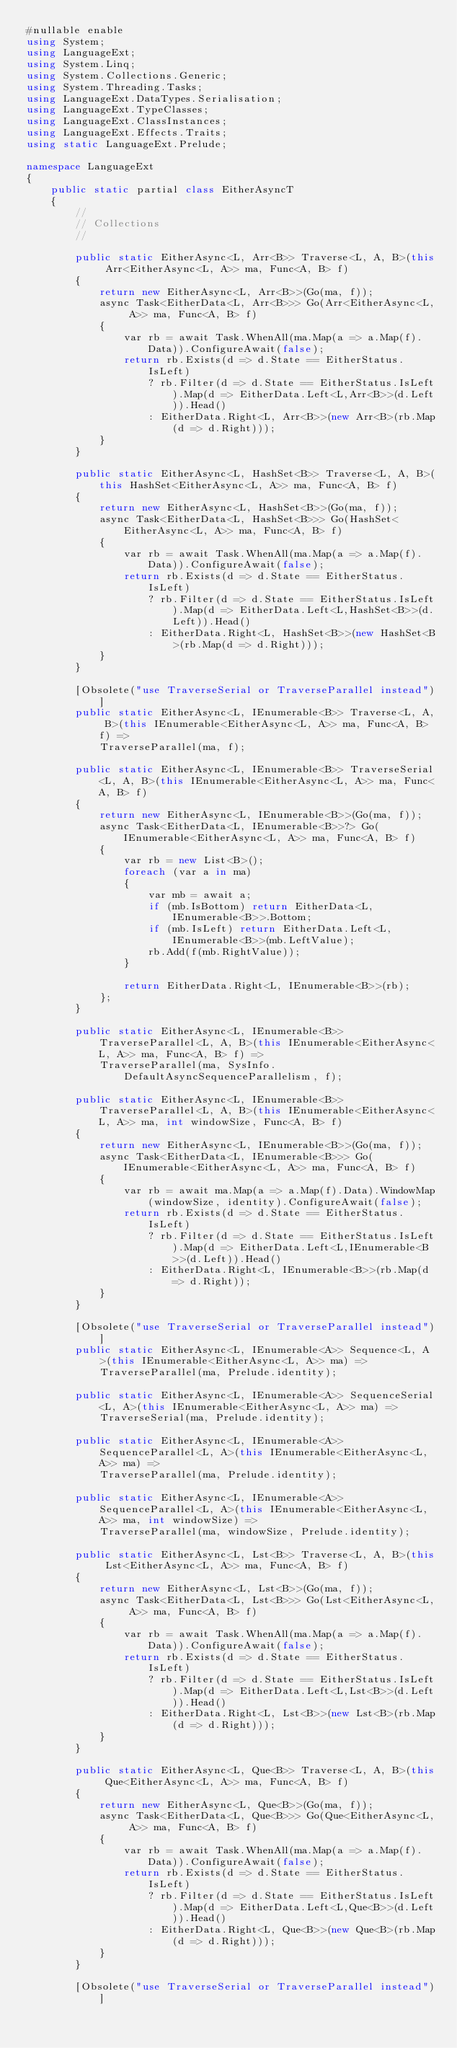<code> <loc_0><loc_0><loc_500><loc_500><_C#_>#nullable enable
using System;
using LanguageExt;
using System.Linq;
using System.Collections.Generic;
using System.Threading.Tasks;
using LanguageExt.DataTypes.Serialisation;
using LanguageExt.TypeClasses;
using LanguageExt.ClassInstances;
using LanguageExt.Effects.Traits;
using static LanguageExt.Prelude;

namespace LanguageExt
{
    public static partial class EitherAsyncT
    {
        //
        // Collections
        //

        public static EitherAsync<L, Arr<B>> Traverse<L, A, B>(this Arr<EitherAsync<L, A>> ma, Func<A, B> f)
        {
            return new EitherAsync<L, Arr<B>>(Go(ma, f));
            async Task<EitherData<L, Arr<B>>> Go(Arr<EitherAsync<L, A>> ma, Func<A, B> f)
            {
                var rb = await Task.WhenAll(ma.Map(a => a.Map(f).Data)).ConfigureAwait(false);
                return rb.Exists(d => d.State == EitherStatus.IsLeft)
                    ? rb.Filter(d => d.State == EitherStatus.IsLeft).Map(d => EitherData.Left<L,Arr<B>>(d.Left)).Head()
                    : EitherData.Right<L, Arr<B>>(new Arr<B>(rb.Map(d => d.Right)));
            }
        }

        public static EitherAsync<L, HashSet<B>> Traverse<L, A, B>(this HashSet<EitherAsync<L, A>> ma, Func<A, B> f)
        {
            return new EitherAsync<L, HashSet<B>>(Go(ma, f));
            async Task<EitherData<L, HashSet<B>>> Go(HashSet<EitherAsync<L, A>> ma, Func<A, B> f)
            {
                var rb = await Task.WhenAll(ma.Map(a => a.Map(f).Data)).ConfigureAwait(false);
                return rb.Exists(d => d.State == EitherStatus.IsLeft)
                    ? rb.Filter(d => d.State == EitherStatus.IsLeft).Map(d => EitherData.Left<L,HashSet<B>>(d.Left)).Head()
                    : EitherData.Right<L, HashSet<B>>(new HashSet<B>(rb.Map(d => d.Right)));
            }
        }
        
        [Obsolete("use TraverseSerial or TraverseParallel instead")]
        public static EitherAsync<L, IEnumerable<B>> Traverse<L, A, B>(this IEnumerable<EitherAsync<L, A>> ma, Func<A, B> f) =>
            TraverseParallel(ma, f);

        public static EitherAsync<L, IEnumerable<B>> TraverseSerial<L, A, B>(this IEnumerable<EitherAsync<L, A>> ma, Func<A, B> f)
        {
            return new EitherAsync<L, IEnumerable<B>>(Go(ma, f));
            async Task<EitherData<L, IEnumerable<B>>?> Go(IEnumerable<EitherAsync<L, A>> ma, Func<A, B> f)
            {
                var rb = new List<B>();
                foreach (var a in ma)
                {
                    var mb = await a;
                    if (mb.IsBottom) return EitherData<L, IEnumerable<B>>.Bottom;
                    if (mb.IsLeft) return EitherData.Left<L, IEnumerable<B>>(mb.LeftValue);
                    rb.Add(f(mb.RightValue));
                }

                return EitherData.Right<L, IEnumerable<B>>(rb);
            };
        }

        public static EitherAsync<L, IEnumerable<B>> TraverseParallel<L, A, B>(this IEnumerable<EitherAsync<L, A>> ma, Func<A, B> f) =>
            TraverseParallel(ma, SysInfo.DefaultAsyncSequenceParallelism, f);
 
        public static EitherAsync<L, IEnumerable<B>> TraverseParallel<L, A, B>(this IEnumerable<EitherAsync<L, A>> ma, int windowSize, Func<A, B> f)
        {
            return new EitherAsync<L, IEnumerable<B>>(Go(ma, f));
            async Task<EitherData<L, IEnumerable<B>>> Go(IEnumerable<EitherAsync<L, A>> ma, Func<A, B> f)
            {
                var rb = await ma.Map(a => a.Map(f).Data).WindowMap(windowSize, identity).ConfigureAwait(false);
                return rb.Exists(d => d.State == EitherStatus.IsLeft)
                    ? rb.Filter(d => d.State == EitherStatus.IsLeft).Map(d => EitherData.Left<L,IEnumerable<B>>(d.Left)).Head()
                    : EitherData.Right<L, IEnumerable<B>>(rb.Map(d => d.Right));
            }
        }
        
        [Obsolete("use TraverseSerial or TraverseParallel instead")]
        public static EitherAsync<L, IEnumerable<A>> Sequence<L, A>(this IEnumerable<EitherAsync<L, A>> ma) =>
            TraverseParallel(ma, Prelude.identity);
 
        public static EitherAsync<L, IEnumerable<A>> SequenceSerial<L, A>(this IEnumerable<EitherAsync<L, A>> ma) =>
            TraverseSerial(ma, Prelude.identity);
 
        public static EitherAsync<L, IEnumerable<A>> SequenceParallel<L, A>(this IEnumerable<EitherAsync<L, A>> ma) =>
            TraverseParallel(ma, Prelude.identity);

        public static EitherAsync<L, IEnumerable<A>> SequenceParallel<L, A>(this IEnumerable<EitherAsync<L, A>> ma, int windowSize) =>
            TraverseParallel(ma, windowSize, Prelude.identity); 

        public static EitherAsync<L, Lst<B>> Traverse<L, A, B>(this Lst<EitherAsync<L, A>> ma, Func<A, B> f)
        {
            return new EitherAsync<L, Lst<B>>(Go(ma, f));
            async Task<EitherData<L, Lst<B>>> Go(Lst<EitherAsync<L, A>> ma, Func<A, B> f)
            {
                var rb = await Task.WhenAll(ma.Map(a => a.Map(f).Data)).ConfigureAwait(false);
                return rb.Exists(d => d.State == EitherStatus.IsLeft)
                    ? rb.Filter(d => d.State == EitherStatus.IsLeft).Map(d => EitherData.Left<L,Lst<B>>(d.Left)).Head()
                    : EitherData.Right<L, Lst<B>>(new Lst<B>(rb.Map(d => d.Right)));
            }
        }

        public static EitherAsync<L, Que<B>> Traverse<L, A, B>(this Que<EitherAsync<L, A>> ma, Func<A, B> f)
        {
            return new EitherAsync<L, Que<B>>(Go(ma, f));
            async Task<EitherData<L, Que<B>>> Go(Que<EitherAsync<L, A>> ma, Func<A, B> f)
            {
                var rb = await Task.WhenAll(ma.Map(a => a.Map(f).Data)).ConfigureAwait(false);
                return rb.Exists(d => d.State == EitherStatus.IsLeft)
                    ? rb.Filter(d => d.State == EitherStatus.IsLeft).Map(d => EitherData.Left<L,Que<B>>(d.Left)).Head()
                    : EitherData.Right<L, Que<B>>(new Que<B>(rb.Map(d => d.Right)));
            }
        }
        
        [Obsolete("use TraverseSerial or TraverseParallel instead")]</code> 